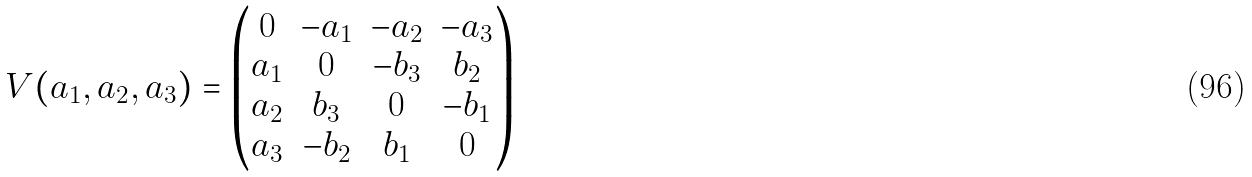<formula> <loc_0><loc_0><loc_500><loc_500>V ( a _ { 1 } , a _ { 2 } , a _ { 3 } ) = \begin{pmatrix} 0 & - a _ { 1 } & - a _ { 2 } & - a _ { 3 } \\ a _ { 1 } & 0 & - b _ { 3 } & b _ { 2 } \\ a _ { 2 } & b _ { 3 } & 0 & - b _ { 1 } \\ a _ { 3 } & - b _ { 2 } & b _ { 1 } & 0 \end{pmatrix}</formula> 